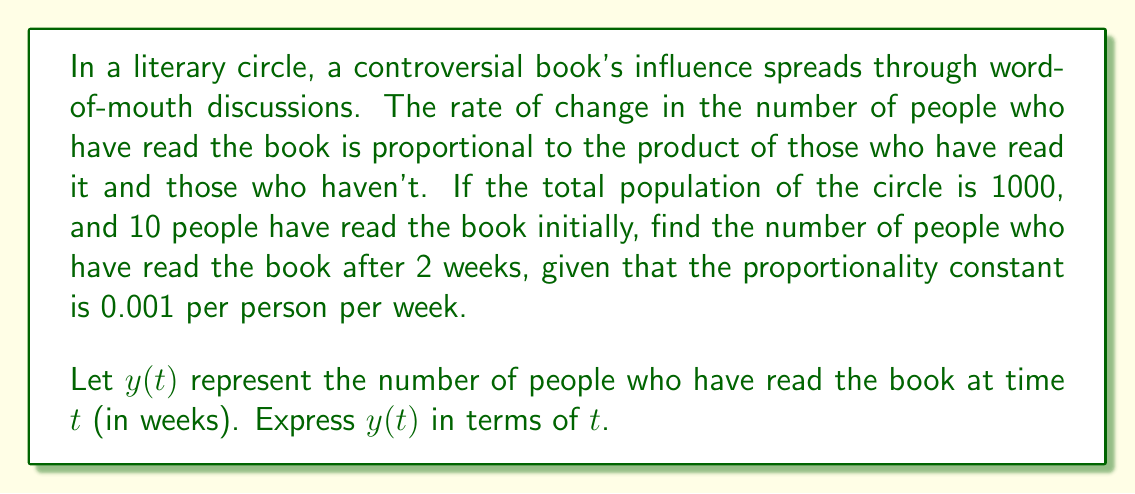Give your solution to this math problem. To solve this problem, we'll use a logistic growth model, which is appropriate for describing the spread of information in a population.

1) First, let's set up the differential equation:
   $$\frac{dy}{dt} = ky(1000-y)$$
   where $k = 0.001$ per person per week

2) This is a separable differential equation. Let's separate the variables:
   $$\frac{dy}{y(1000-y)} = 0.001dt$$

3) Integrate both sides:
   $$\int \frac{dy}{y(1000-y)} = \int 0.001dt$$

4) The left side can be integrated using partial fractions:
   $$\frac{1}{1000}\ln|\frac{y}{1000-y}| = 0.001t + C$$

5) Solve for $y$:
   $$\frac{y}{1000-y} = Ae^{t}$$
   where $A = 1000e^{0.001C}$

6) Simplify:
   $$y = \frac{1000Ae^{t}}{1+Ae^{t}}$$

7) Use the initial condition $y(0) = 10$ to find $A$:
   $$10 = \frac{1000A}{1+A}$$
   $$A = \frac{1}{99}$$

8) Therefore, the solution is:
   $$y(t) = \frac{1000(\frac{1}{99})e^{t}}{1+(\frac{1}{99})e^{t}}$$

9) Simplify:
   $$y(t) = \frac{1000}{1+99e^{-t}}$$

This equation gives the number of people who have read the book after $t$ weeks.
Answer: $y(t) = \frac{1000}{1+99e^{-t}}$

After 2 weeks: $y(2) = \frac{1000}{1+99e^{-2}} \approx 75$ people (rounded to the nearest whole number) 